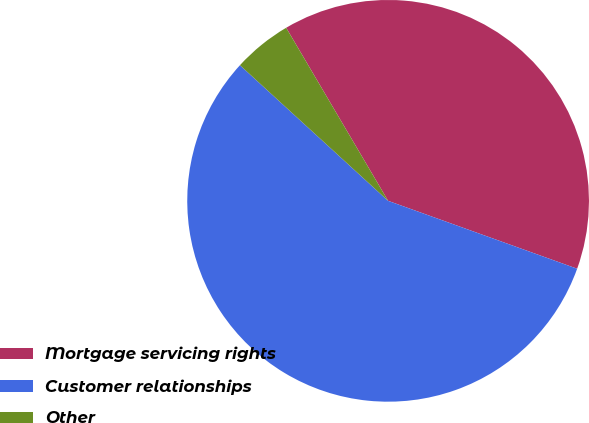Convert chart to OTSL. <chart><loc_0><loc_0><loc_500><loc_500><pie_chart><fcel>Mortgage servicing rights<fcel>Customer relationships<fcel>Other<nl><fcel>38.96%<fcel>56.31%<fcel>4.73%<nl></chart> 